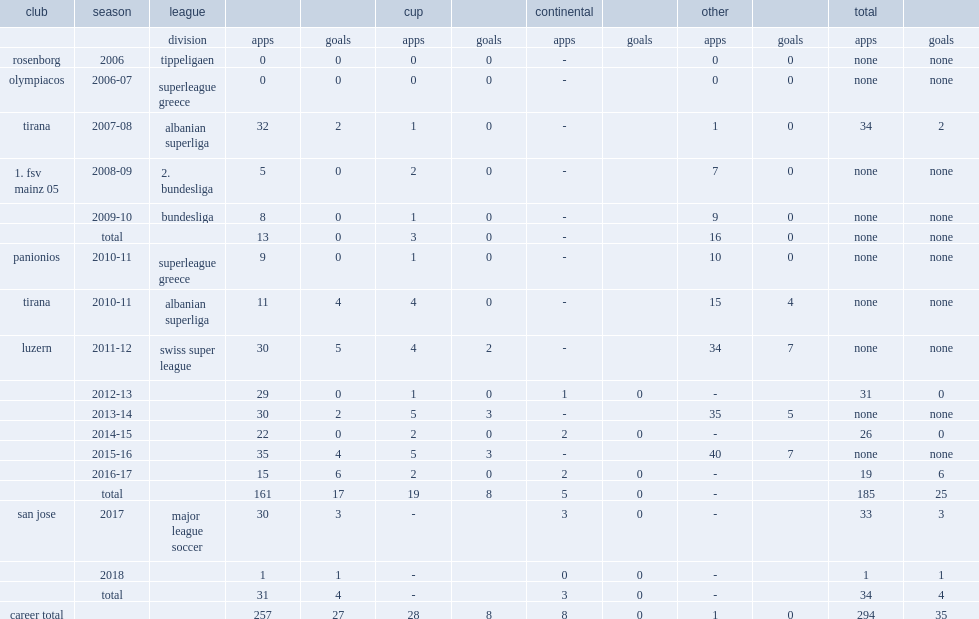Would you mind parsing the complete table? {'header': ['club', 'season', 'league', '', '', 'cup', '', 'continental', '', 'other', '', 'total', ''], 'rows': [['', '', 'division', 'apps', 'goals', 'apps', 'goals', 'apps', 'goals', 'apps', 'goals', 'apps', 'goals'], ['rosenborg', '2006', 'tippeligaen', '0', '0', '0', '0', '-', '', '0', '0', 'none', 'none'], ['olympiacos', '2006-07', 'superleague greece', '0', '0', '0', '0', '-', '', '0', '0', 'none', 'none'], ['tirana', '2007-08', 'albanian superliga', '32', '2', '1', '0', '-', '', '1', '0', '34', '2'], ['1. fsv mainz 05', '2008-09', '2. bundesliga', '5', '0', '2', '0', '-', '', '7', '0', 'none', 'none'], ['', '2009-10', 'bundesliga', '8', '0', '1', '0', '-', '', '9', '0', 'none', 'none'], ['', 'total', '', '13', '0', '3', '0', '-', '', '16', '0', 'none', 'none'], ['panionios', '2010-11', 'superleague greece', '9', '0', '1', '0', '-', '', '10', '0', 'none', 'none'], ['tirana', '2010-11', 'albanian superliga', '11', '4', '4', '0', '-', '', '15', '4', 'none', 'none'], ['luzern', '2011-12', 'swiss super league', '30', '5', '4', '2', '-', '', '34', '7', 'none', 'none'], ['', '2012-13', '', '29', '0', '1', '0', '1', '0', '-', '', '31', '0'], ['', '2013-14', '', '30', '2', '5', '3', '-', '', '35', '5', 'none', 'none'], ['', '2014-15', '', '22', '0', '2', '0', '2', '0', '-', '', '26', '0'], ['', '2015-16', '', '35', '4', '5', '3', '-', '', '40', '7', 'none', 'none'], ['', '2016-17', '', '15', '6', '2', '0', '2', '0', '-', '', '19', '6'], ['', 'total', '', '161', '17', '19', '8', '5', '0', '-', '', '185', '25'], ['san jose', '2017', 'major league soccer', '30', '3', '-', '', '3', '0', '-', '', '33', '3'], ['', '2018', '', '1', '1', '-', '', '0', '0', '-', '', '1', '1'], ['', 'total', '', '31', '4', '-', '', '3', '0', '-', '', '34', '4'], ['career total', '', '', '257', '27', '28', '8', '8', '0', '1', '0', '294', '35']]} In 2017, which league did hyka signe with san jose in? Major league soccer. 